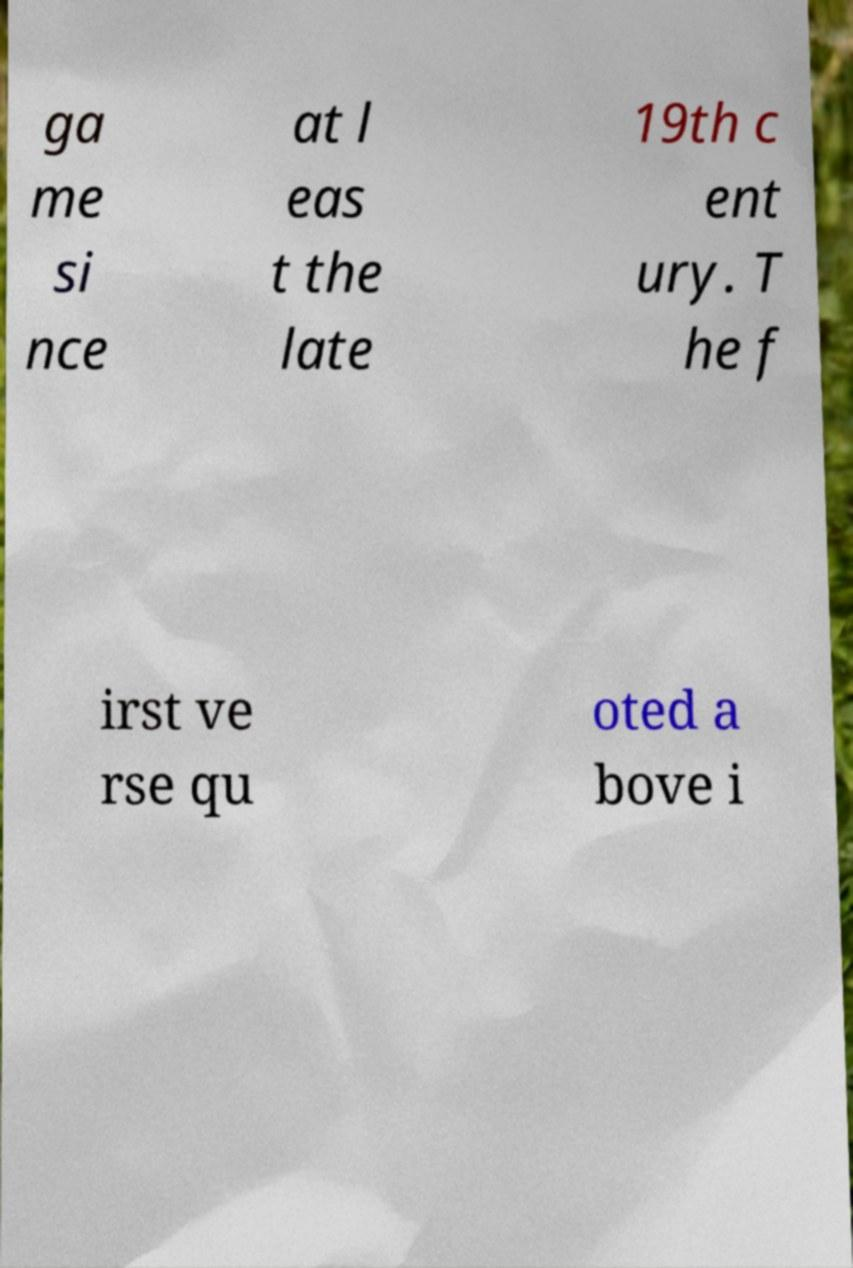Please read and relay the text visible in this image. What does it say? ga me si nce at l eas t the late 19th c ent ury. T he f irst ve rse qu oted a bove i 